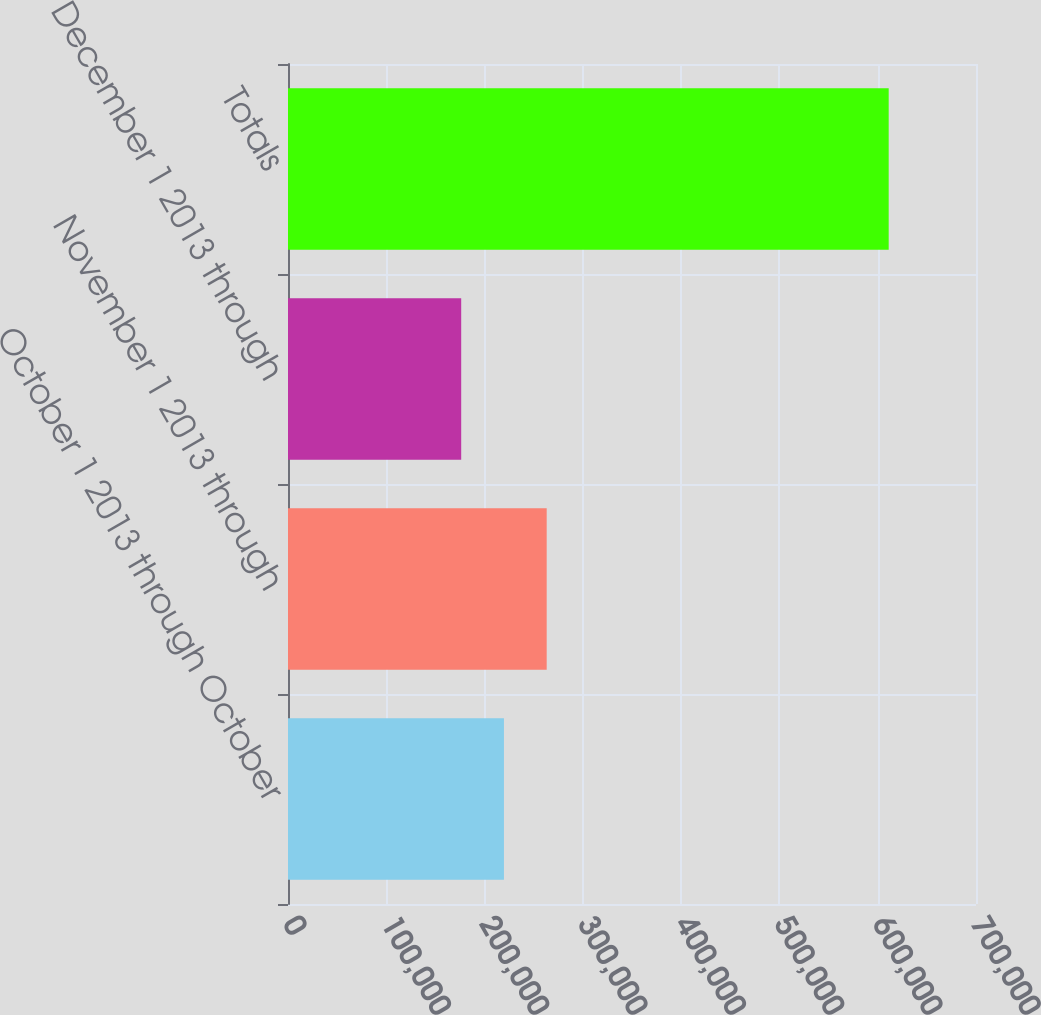Convert chart to OTSL. <chart><loc_0><loc_0><loc_500><loc_500><bar_chart><fcel>October 1 2013 through October<fcel>November 1 2013 through<fcel>December 1 2013 through<fcel>Totals<nl><fcel>219711<fcel>263205<fcel>176216<fcel>611163<nl></chart> 